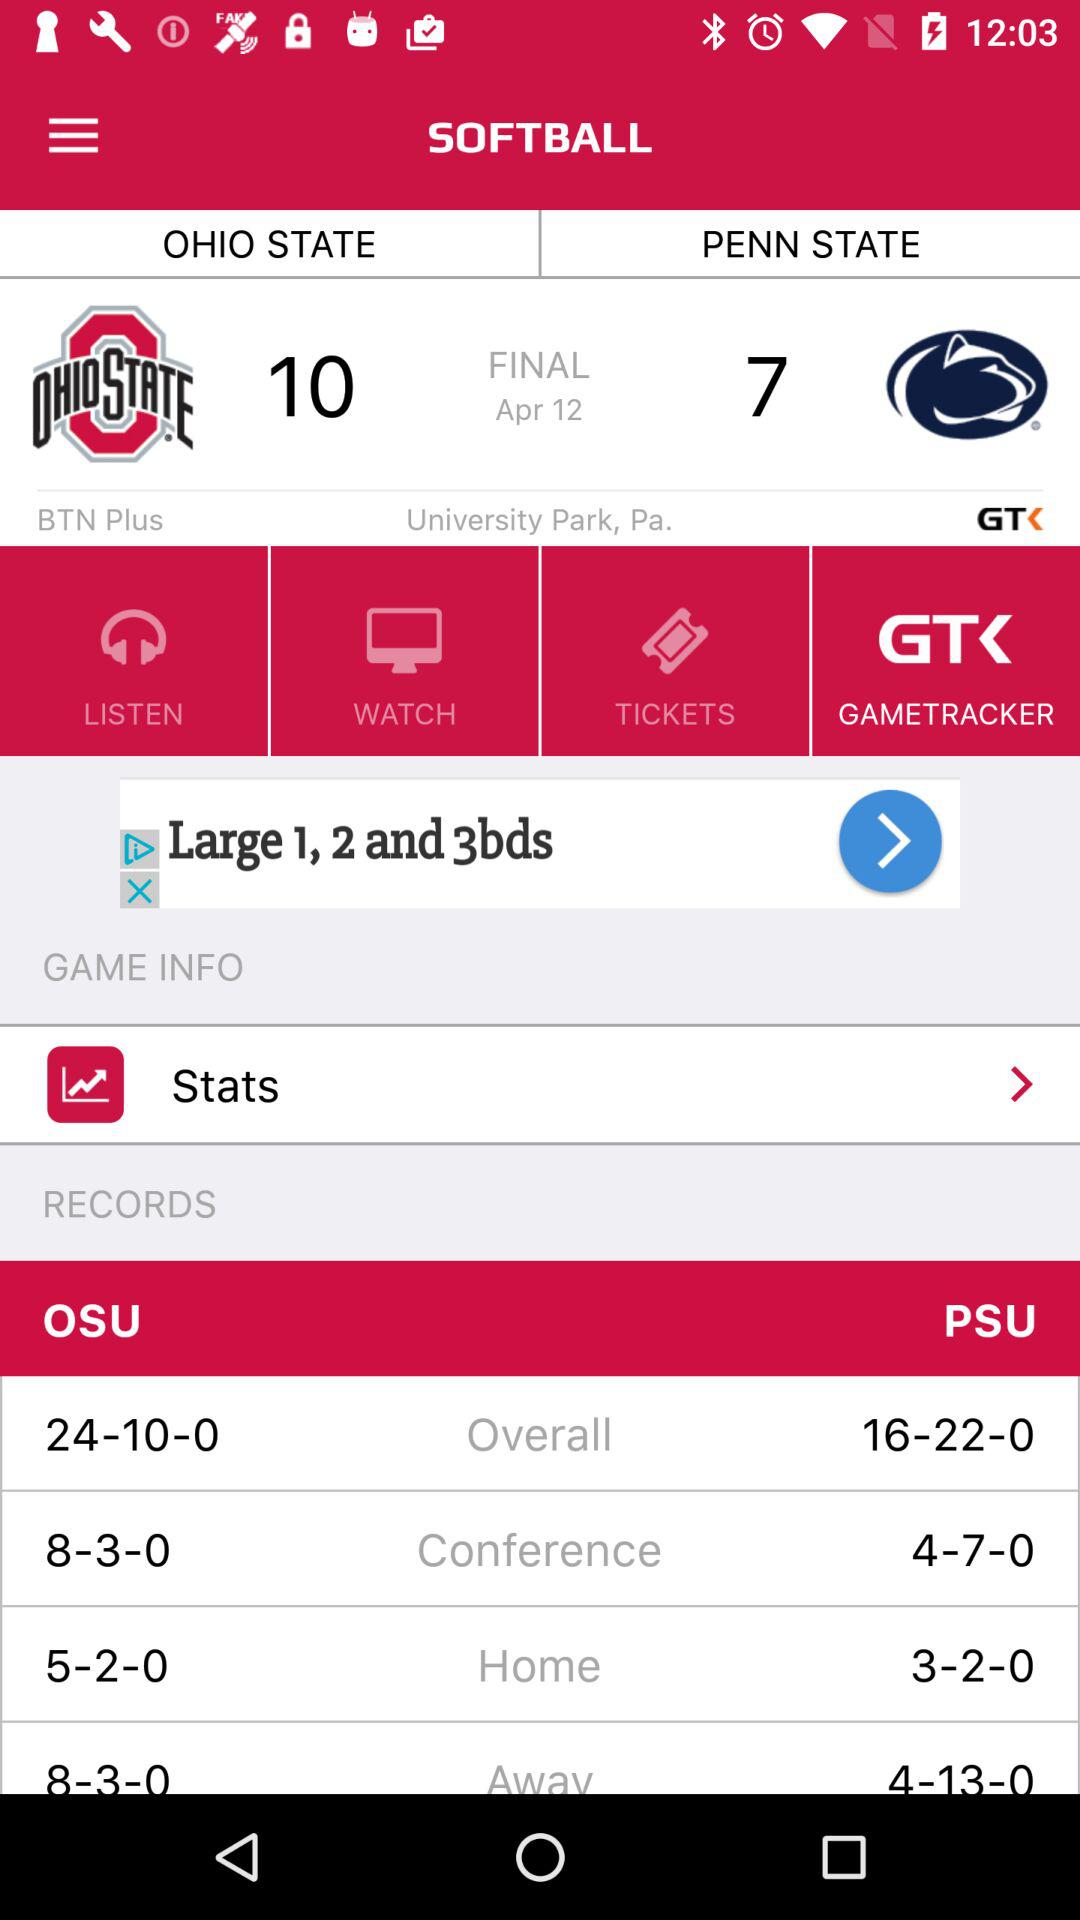What is the name of the game? The name of the game is "SOFTBALL". 